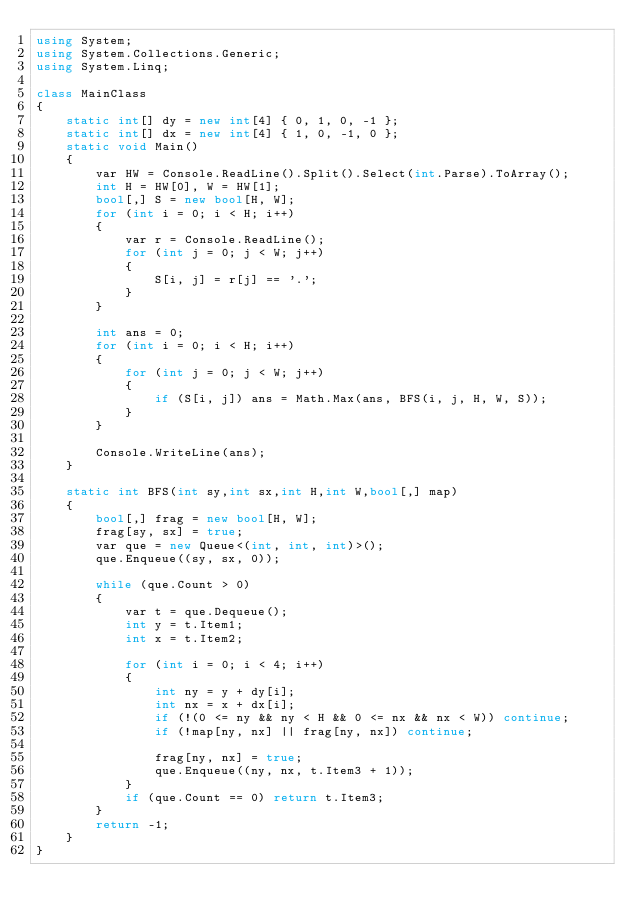Convert code to text. <code><loc_0><loc_0><loc_500><loc_500><_C#_>using System;
using System.Collections.Generic;
using System.Linq;

class MainClass
{
    static int[] dy = new int[4] { 0, 1, 0, -1 };
    static int[] dx = new int[4] { 1, 0, -1, 0 };
    static void Main()
    {
        var HW = Console.ReadLine().Split().Select(int.Parse).ToArray();
        int H = HW[0], W = HW[1];
        bool[,] S = new bool[H, W];
        for (int i = 0; i < H; i++)
        {
            var r = Console.ReadLine();
            for (int j = 0; j < W; j++)
            {
                S[i, j] = r[j] == '.';
            }
        }

        int ans = 0;
        for (int i = 0; i < H; i++)
        {
            for (int j = 0; j < W; j++)
            {
                if (S[i, j]) ans = Math.Max(ans, BFS(i, j, H, W, S));
            }
        }

        Console.WriteLine(ans);
    }

    static int BFS(int sy,int sx,int H,int W,bool[,] map)
    {
        bool[,] frag = new bool[H, W];
        frag[sy, sx] = true;
        var que = new Queue<(int, int, int)>();
        que.Enqueue((sy, sx, 0));

        while (que.Count > 0)
        {
            var t = que.Dequeue();
            int y = t.Item1;
            int x = t.Item2;

            for (int i = 0; i < 4; i++)
            {
                int ny = y + dy[i];
                int nx = x + dx[i];
                if (!(0 <= ny && ny < H && 0 <= nx && nx < W)) continue;
                if (!map[ny, nx] || frag[ny, nx]) continue;

                frag[ny, nx] = true;
                que.Enqueue((ny, nx, t.Item3 + 1));
            }
            if (que.Count == 0) return t.Item3;
        }
        return -1;
    }
}</code> 